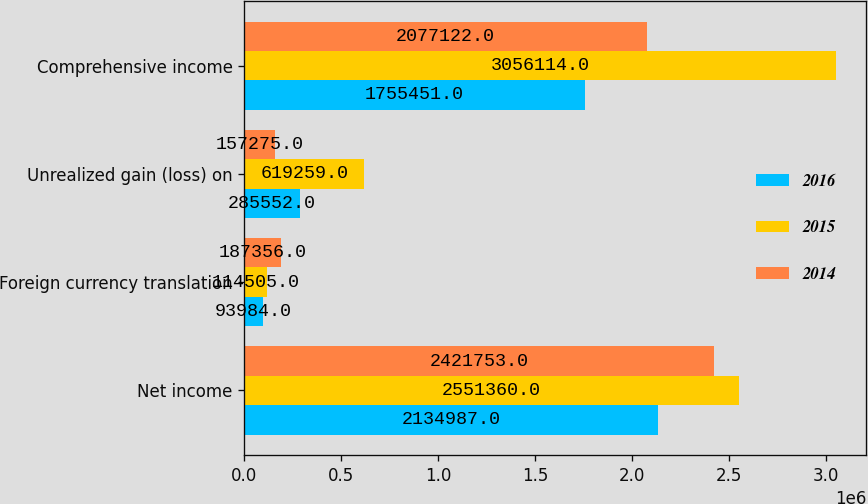Convert chart to OTSL. <chart><loc_0><loc_0><loc_500><loc_500><stacked_bar_chart><ecel><fcel>Net income<fcel>Foreign currency translation<fcel>Unrealized gain (loss) on<fcel>Comprehensive income<nl><fcel>2016<fcel>2.13499e+06<fcel>93984<fcel>285552<fcel>1.75545e+06<nl><fcel>2015<fcel>2.55136e+06<fcel>114505<fcel>619259<fcel>3.05611e+06<nl><fcel>2014<fcel>2.42175e+06<fcel>187356<fcel>157275<fcel>2.07712e+06<nl></chart> 